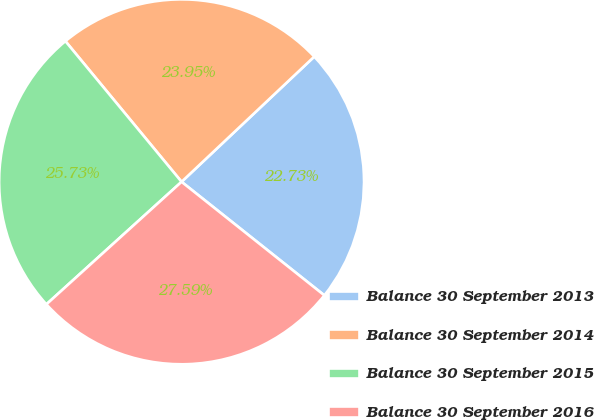<chart> <loc_0><loc_0><loc_500><loc_500><pie_chart><fcel>Balance 30 September 2013<fcel>Balance 30 September 2014<fcel>Balance 30 September 2015<fcel>Balance 30 September 2016<nl><fcel>22.73%<fcel>23.95%<fcel>25.73%<fcel>27.59%<nl></chart> 